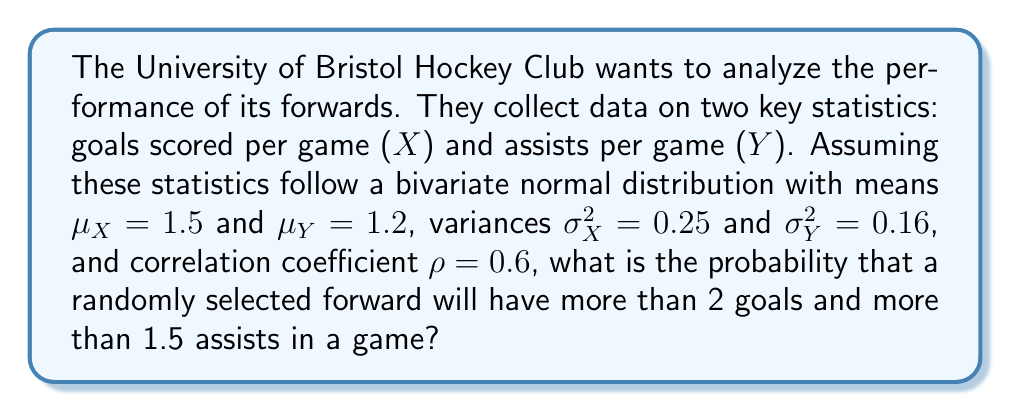Provide a solution to this math problem. To solve this problem, we need to use the properties of the multivariate normal distribution. Let's approach this step-by-step:

1) First, we need to standardize our variables. Let Z1 represent the standardized goals and Z2 represent the standardized assists:

   $Z1 = \frac{X - \mu_X}{\sigma_X} = \frac{X - 1.5}{0.5}$
   $Z2 = \frac{Y - \mu_Y}{\sigma_Y} = \frac{Y - 1.2}{0.4}$

2) We want to find P(X > 2, Y > 1.5), which is equivalent to:

   $P(Z1 > \frac{2 - 1.5}{0.5}, Z2 > \frac{1.5 - 1.2}{0.4})$
   $= P(Z1 > 1, Z2 > 0.75)$

3) Now we have a standardized bivariate normal distribution with correlation $\rho = 0.6$.

4) To calculate this probability, we need to use the cumulative distribution function (CDF) of the bivariate normal distribution, which is typically denoted as $\Phi_2(x, y; \rho)$.

5) The probability we're looking for is:

   $1 - \Phi_2(1, 0.75; 0.6)$

6) Unfortunately, there's no simple closed-form expression for this probability. It needs to be calculated using numerical methods or statistical software.

7) Using a statistical software or a bivariate normal distribution calculator, we can find that:

   $\Phi_2(1, 0.75; 0.6) \approx 0.8683$

8) Therefore, the probability we're looking for is:

   $1 - 0.8683 \approx 0.1317$ or about 13.17%
Answer: 0.1317 or 13.17% 